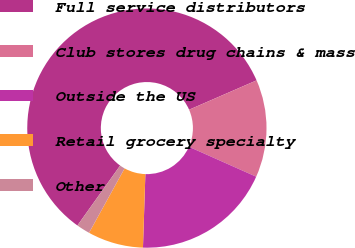<chart> <loc_0><loc_0><loc_500><loc_500><pie_chart><fcel>Full service distributors<fcel>Club stores drug chains & mass<fcel>Outside the US<fcel>Retail grocery specialty<fcel>Other<nl><fcel>58.61%<fcel>13.19%<fcel>18.86%<fcel>7.51%<fcel>1.83%<nl></chart> 